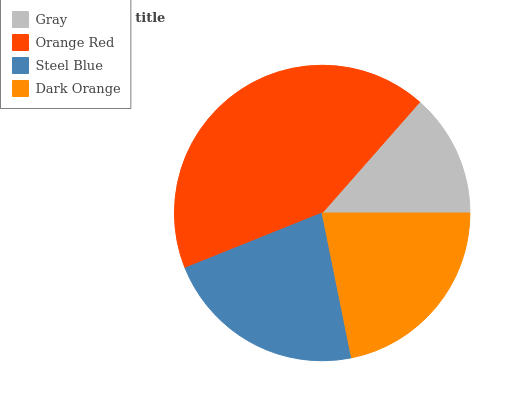Is Gray the minimum?
Answer yes or no. Yes. Is Orange Red the maximum?
Answer yes or no. Yes. Is Steel Blue the minimum?
Answer yes or no. No. Is Steel Blue the maximum?
Answer yes or no. No. Is Orange Red greater than Steel Blue?
Answer yes or no. Yes. Is Steel Blue less than Orange Red?
Answer yes or no. Yes. Is Steel Blue greater than Orange Red?
Answer yes or no. No. Is Orange Red less than Steel Blue?
Answer yes or no. No. Is Steel Blue the high median?
Answer yes or no. Yes. Is Dark Orange the low median?
Answer yes or no. Yes. Is Gray the high median?
Answer yes or no. No. Is Steel Blue the low median?
Answer yes or no. No. 